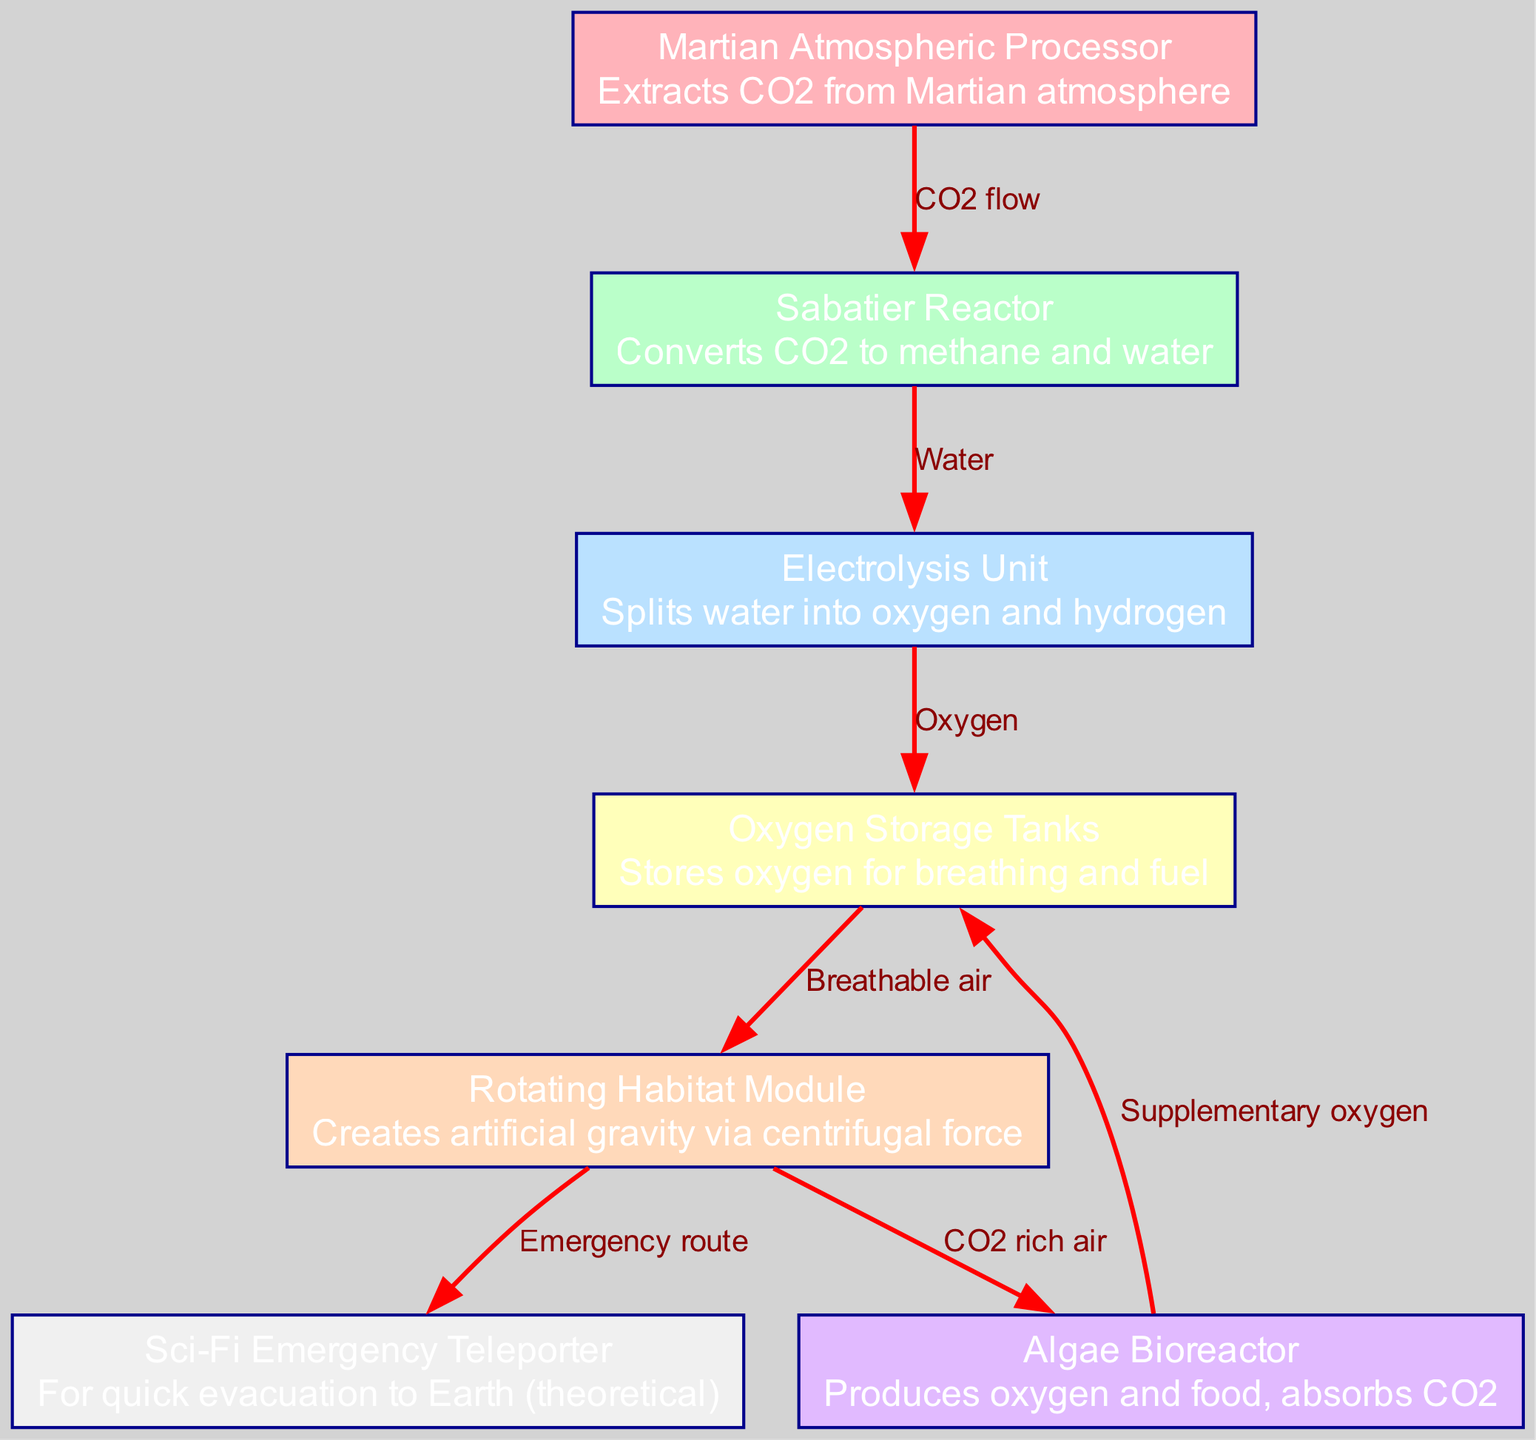What is the function of node 1? Node 1 is labeled "Martian Atmospheric Processor" and its description states it "extracts CO2 from Martian atmosphere," indicating its primary function of processing the Martian air for usable carbon dioxide.
Answer: Extracts CO2 from Martian atmosphere How many nodes are there in the diagram? By counting the nodes listed in the diagram, we find a total of 7 distinct nodes, each representing a component of the life support system.
Answer: 7 What is the flow direction from node 2 to node 3? The edge between node 2 ("Sabatier Reactor") and node 3 ("Electrolysis Unit") is labeled "Water," which indicates that water is produced as a by-product of the CO2 conversion process.
Answer: Water Which node produces supplementary oxygen? Node 6 is labeled "Algae Bioreactor," and its description mentions that it "produces oxygen and food, absorbs CO2," indicating its role in generating extra oxygen necessary for the colony.
Answer: Algae Bioreactor What is the primary purpose of the "Rotating Habitat Module"? Node 5 is labeled "Rotating Habitat Module," with the description stating that it creates "artificial gravity via centrifugal force," highlighting its essential role in maintaining a livable environment for the colonists.
Answer: Creates artificial gravity What relationship does the "Oxygen Storage Tanks" have with the "Martian Atmospheric Processor"? The "Oxygen Storage Tanks" (node 4) receive "breathable air" from the "Rotating Habitat Module" (node 5) which in turn processes CO2 from the "Martian Atmospheric Processor" (node 1). The flow illustrates a dependency where the processor contributes to the oxygen supply stored in node 4.
Answer: Oxygen for breathing and fuel What is the theoretical function of the "Sci-Fi Emergency Teleporter"? The "Sci-Fi Emergency Teleporter," labeled as node 7, is described as a mechanism for "quick evacuation to Earth (theoretical)," indicating its speculative nature for emergency situations in the colony setup.
Answer: For quick evacuation to Earth Which node sends CO2 rich air to the Algae Bioreactor? The "Rotating Habitat Module" (node 5) sends "CO2 rich air" to the "Algae Bioreactor" (node 6), utilizing waste gases to support photosynthesis within the bioreactor for oxygen and food production.
Answer: Rotating Habitat Module How does the "Electrolysis Unit" contribute to the life support system? The "Electrolysis Unit" (node 3) operates by splitting water into oxygen and hydrogen, which directly supports the availability of oxygen needed for breathing by the colony's inhabitants.
Answer: Splits water into oxygen and hydrogen 